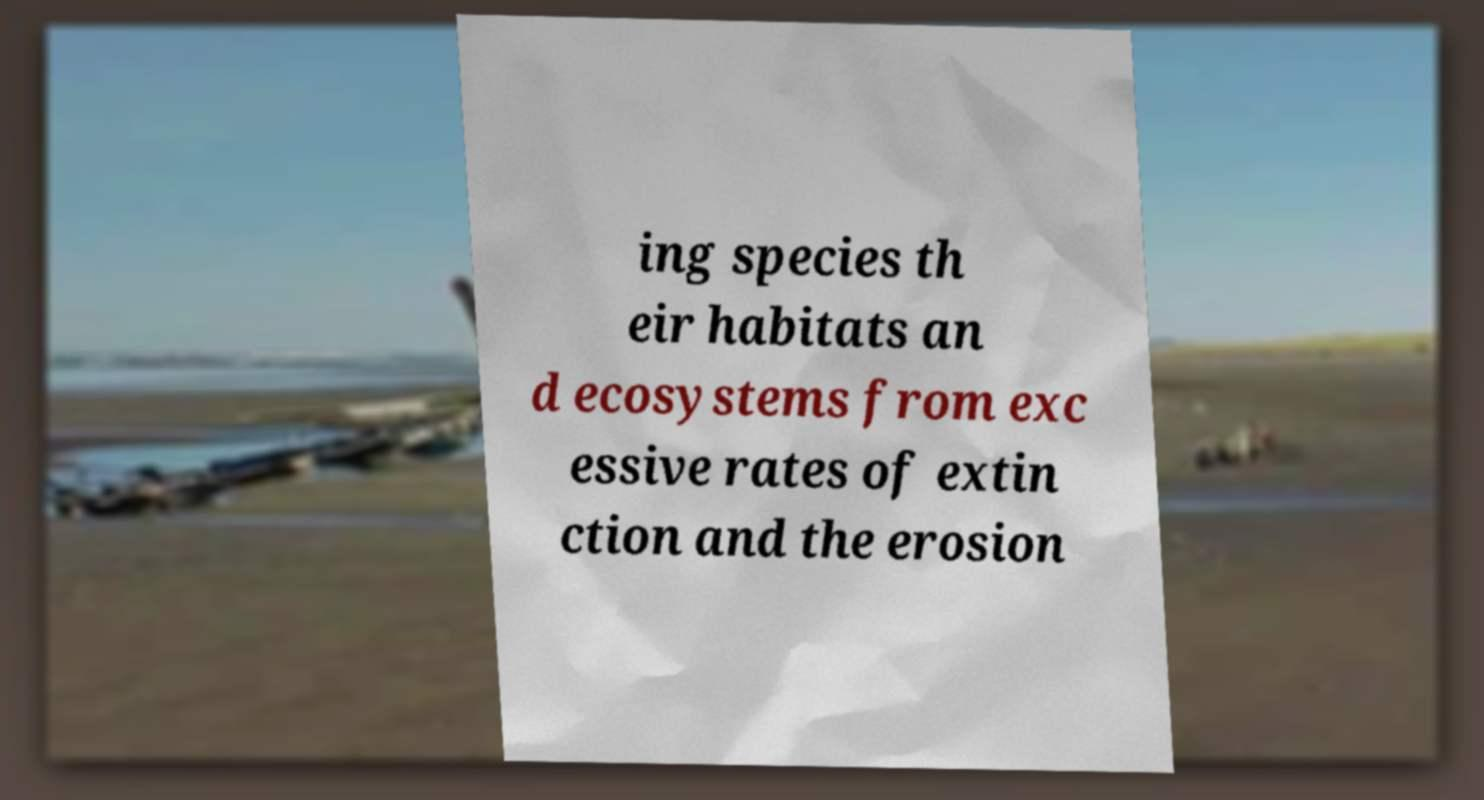For documentation purposes, I need the text within this image transcribed. Could you provide that? ing species th eir habitats an d ecosystems from exc essive rates of extin ction and the erosion 